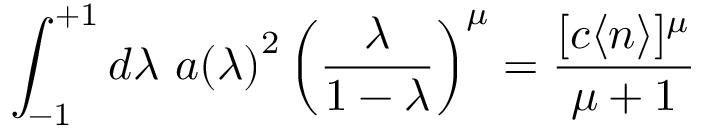<formula> <loc_0><loc_0><loc_500><loc_500>\int _ { - 1 } ^ { + 1 } d \lambda \ { a ( \lambda ) } ^ { 2 } \left ( \frac { \lambda } { 1 - \lambda } \right ) ^ { \mu } = \frac { [ c \langle n \rangle ] ^ { \mu } } { \mu + 1 }</formula> 